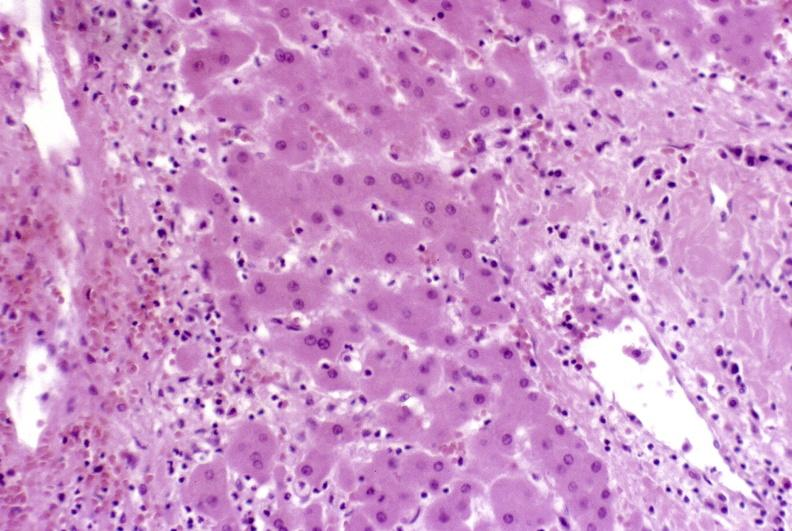s hepatobiliary present?
Answer the question using a single word or phrase. Yes 